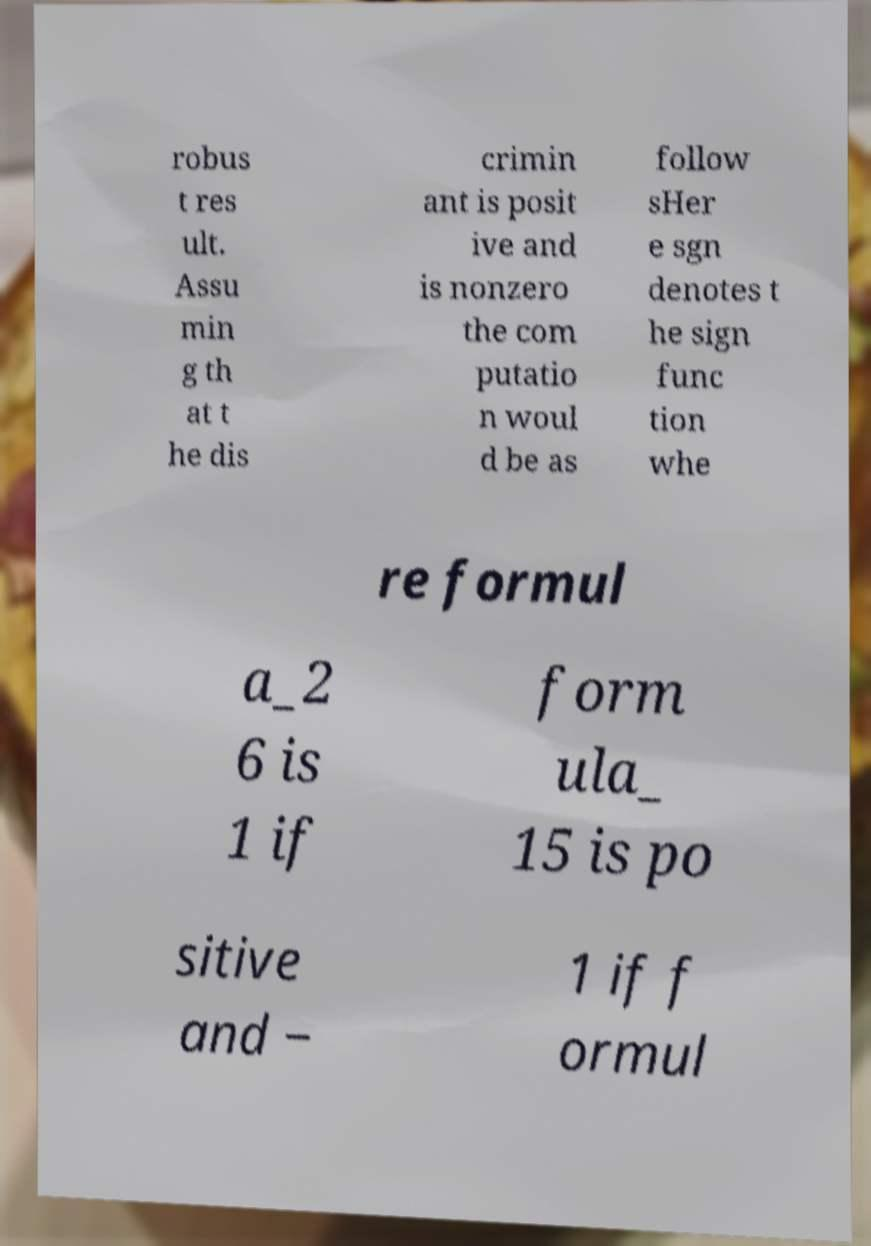Can you accurately transcribe the text from the provided image for me? robus t res ult. Assu min g th at t he dis crimin ant is posit ive and is nonzero the com putatio n woul d be as follow sHer e sgn denotes t he sign func tion whe re formul a_2 6 is 1 if form ula_ 15 is po sitive and − 1 if f ormul 